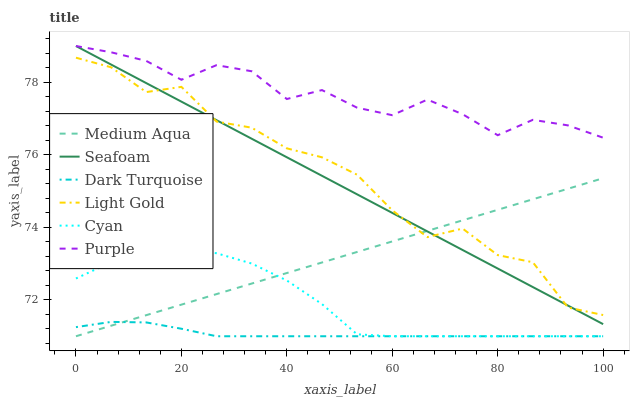Does Dark Turquoise have the minimum area under the curve?
Answer yes or no. Yes. Does Purple have the maximum area under the curve?
Answer yes or no. Yes. Does Seafoam have the minimum area under the curve?
Answer yes or no. No. Does Seafoam have the maximum area under the curve?
Answer yes or no. No. Is Seafoam the smoothest?
Answer yes or no. Yes. Is Light Gold the roughest?
Answer yes or no. Yes. Is Dark Turquoise the smoothest?
Answer yes or no. No. Is Dark Turquoise the roughest?
Answer yes or no. No. Does Dark Turquoise have the lowest value?
Answer yes or no. Yes. Does Seafoam have the lowest value?
Answer yes or no. No. Does Seafoam have the highest value?
Answer yes or no. Yes. Does Dark Turquoise have the highest value?
Answer yes or no. No. Is Dark Turquoise less than Seafoam?
Answer yes or no. Yes. Is Light Gold greater than Dark Turquoise?
Answer yes or no. Yes. Does Cyan intersect Dark Turquoise?
Answer yes or no. Yes. Is Cyan less than Dark Turquoise?
Answer yes or no. No. Is Cyan greater than Dark Turquoise?
Answer yes or no. No. Does Dark Turquoise intersect Seafoam?
Answer yes or no. No. 